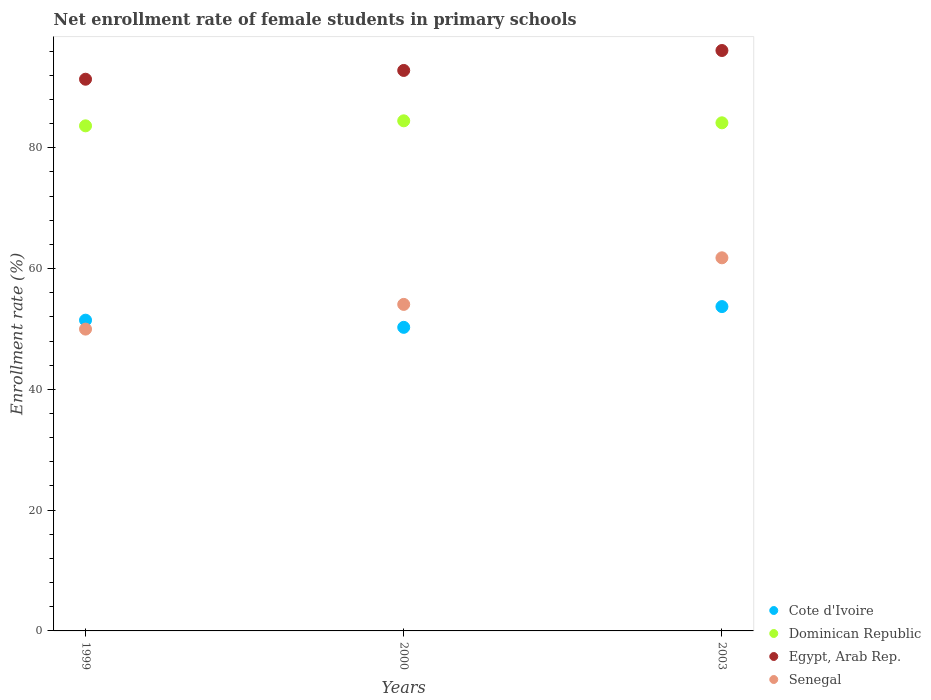Is the number of dotlines equal to the number of legend labels?
Keep it short and to the point. Yes. What is the net enrollment rate of female students in primary schools in Dominican Republic in 2003?
Give a very brief answer. 84.14. Across all years, what is the maximum net enrollment rate of female students in primary schools in Senegal?
Your response must be concise. 61.79. Across all years, what is the minimum net enrollment rate of female students in primary schools in Egypt, Arab Rep.?
Offer a very short reply. 91.36. In which year was the net enrollment rate of female students in primary schools in Egypt, Arab Rep. maximum?
Give a very brief answer. 2003. In which year was the net enrollment rate of female students in primary schools in Senegal minimum?
Provide a short and direct response. 1999. What is the total net enrollment rate of female students in primary schools in Senegal in the graph?
Provide a short and direct response. 165.84. What is the difference between the net enrollment rate of female students in primary schools in Egypt, Arab Rep. in 2000 and that in 2003?
Your response must be concise. -3.3. What is the difference between the net enrollment rate of female students in primary schools in Dominican Republic in 1999 and the net enrollment rate of female students in primary schools in Senegal in 2000?
Keep it short and to the point. 29.57. What is the average net enrollment rate of female students in primary schools in Cote d'Ivoire per year?
Give a very brief answer. 51.81. In the year 2003, what is the difference between the net enrollment rate of female students in primary schools in Egypt, Arab Rep. and net enrollment rate of female students in primary schools in Cote d'Ivoire?
Your response must be concise. 42.41. What is the ratio of the net enrollment rate of female students in primary schools in Dominican Republic in 1999 to that in 2000?
Your response must be concise. 0.99. What is the difference between the highest and the second highest net enrollment rate of female students in primary schools in Dominican Republic?
Make the answer very short. 0.33. What is the difference between the highest and the lowest net enrollment rate of female students in primary schools in Cote d'Ivoire?
Keep it short and to the point. 3.44. Is the sum of the net enrollment rate of female students in primary schools in Dominican Republic in 1999 and 2000 greater than the maximum net enrollment rate of female students in primary schools in Cote d'Ivoire across all years?
Offer a very short reply. Yes. Is it the case that in every year, the sum of the net enrollment rate of female students in primary schools in Egypt, Arab Rep. and net enrollment rate of female students in primary schools in Senegal  is greater than the net enrollment rate of female students in primary schools in Dominican Republic?
Provide a short and direct response. Yes. Does the net enrollment rate of female students in primary schools in Senegal monotonically increase over the years?
Provide a short and direct response. Yes. Is the net enrollment rate of female students in primary schools in Senegal strictly greater than the net enrollment rate of female students in primary schools in Egypt, Arab Rep. over the years?
Offer a very short reply. No. Is the net enrollment rate of female students in primary schools in Dominican Republic strictly less than the net enrollment rate of female students in primary schools in Senegal over the years?
Make the answer very short. No. How many dotlines are there?
Keep it short and to the point. 4. How many years are there in the graph?
Offer a terse response. 3. Does the graph contain any zero values?
Your answer should be very brief. No. Does the graph contain grids?
Make the answer very short. No. Where does the legend appear in the graph?
Make the answer very short. Bottom right. How many legend labels are there?
Ensure brevity in your answer.  4. How are the legend labels stacked?
Offer a very short reply. Vertical. What is the title of the graph?
Offer a very short reply. Net enrollment rate of female students in primary schools. What is the label or title of the Y-axis?
Keep it short and to the point. Enrollment rate (%). What is the Enrollment rate (%) in Cote d'Ivoire in 1999?
Keep it short and to the point. 51.46. What is the Enrollment rate (%) in Dominican Republic in 1999?
Your answer should be very brief. 83.64. What is the Enrollment rate (%) in Egypt, Arab Rep. in 1999?
Your answer should be very brief. 91.36. What is the Enrollment rate (%) in Senegal in 1999?
Give a very brief answer. 49.98. What is the Enrollment rate (%) of Cote d'Ivoire in 2000?
Provide a short and direct response. 50.27. What is the Enrollment rate (%) in Dominican Republic in 2000?
Your answer should be compact. 84.47. What is the Enrollment rate (%) in Egypt, Arab Rep. in 2000?
Ensure brevity in your answer.  92.81. What is the Enrollment rate (%) of Senegal in 2000?
Keep it short and to the point. 54.07. What is the Enrollment rate (%) in Cote d'Ivoire in 2003?
Your answer should be compact. 53.71. What is the Enrollment rate (%) of Dominican Republic in 2003?
Provide a short and direct response. 84.14. What is the Enrollment rate (%) in Egypt, Arab Rep. in 2003?
Your answer should be compact. 96.12. What is the Enrollment rate (%) of Senegal in 2003?
Offer a very short reply. 61.79. Across all years, what is the maximum Enrollment rate (%) in Cote d'Ivoire?
Provide a short and direct response. 53.71. Across all years, what is the maximum Enrollment rate (%) of Dominican Republic?
Give a very brief answer. 84.47. Across all years, what is the maximum Enrollment rate (%) of Egypt, Arab Rep.?
Make the answer very short. 96.12. Across all years, what is the maximum Enrollment rate (%) of Senegal?
Keep it short and to the point. 61.79. Across all years, what is the minimum Enrollment rate (%) in Cote d'Ivoire?
Keep it short and to the point. 50.27. Across all years, what is the minimum Enrollment rate (%) of Dominican Republic?
Give a very brief answer. 83.64. Across all years, what is the minimum Enrollment rate (%) of Egypt, Arab Rep.?
Keep it short and to the point. 91.36. Across all years, what is the minimum Enrollment rate (%) in Senegal?
Keep it short and to the point. 49.98. What is the total Enrollment rate (%) in Cote d'Ivoire in the graph?
Make the answer very short. 155.44. What is the total Enrollment rate (%) of Dominican Republic in the graph?
Offer a very short reply. 252.25. What is the total Enrollment rate (%) of Egypt, Arab Rep. in the graph?
Keep it short and to the point. 280.29. What is the total Enrollment rate (%) in Senegal in the graph?
Your answer should be compact. 165.84. What is the difference between the Enrollment rate (%) in Cote d'Ivoire in 1999 and that in 2000?
Ensure brevity in your answer.  1.19. What is the difference between the Enrollment rate (%) of Dominican Republic in 1999 and that in 2000?
Your answer should be compact. -0.83. What is the difference between the Enrollment rate (%) in Egypt, Arab Rep. in 1999 and that in 2000?
Keep it short and to the point. -1.45. What is the difference between the Enrollment rate (%) in Senegal in 1999 and that in 2000?
Ensure brevity in your answer.  -4.09. What is the difference between the Enrollment rate (%) in Cote d'Ivoire in 1999 and that in 2003?
Ensure brevity in your answer.  -2.25. What is the difference between the Enrollment rate (%) in Dominican Republic in 1999 and that in 2003?
Your answer should be very brief. -0.5. What is the difference between the Enrollment rate (%) in Egypt, Arab Rep. in 1999 and that in 2003?
Your answer should be very brief. -4.76. What is the difference between the Enrollment rate (%) of Senegal in 1999 and that in 2003?
Provide a short and direct response. -11.81. What is the difference between the Enrollment rate (%) in Cote d'Ivoire in 2000 and that in 2003?
Your answer should be very brief. -3.44. What is the difference between the Enrollment rate (%) of Dominican Republic in 2000 and that in 2003?
Ensure brevity in your answer.  0.33. What is the difference between the Enrollment rate (%) in Egypt, Arab Rep. in 2000 and that in 2003?
Your response must be concise. -3.3. What is the difference between the Enrollment rate (%) of Senegal in 2000 and that in 2003?
Your answer should be very brief. -7.72. What is the difference between the Enrollment rate (%) in Cote d'Ivoire in 1999 and the Enrollment rate (%) in Dominican Republic in 2000?
Give a very brief answer. -33.01. What is the difference between the Enrollment rate (%) of Cote d'Ivoire in 1999 and the Enrollment rate (%) of Egypt, Arab Rep. in 2000?
Keep it short and to the point. -41.35. What is the difference between the Enrollment rate (%) in Cote d'Ivoire in 1999 and the Enrollment rate (%) in Senegal in 2000?
Provide a short and direct response. -2.61. What is the difference between the Enrollment rate (%) in Dominican Republic in 1999 and the Enrollment rate (%) in Egypt, Arab Rep. in 2000?
Ensure brevity in your answer.  -9.17. What is the difference between the Enrollment rate (%) of Dominican Republic in 1999 and the Enrollment rate (%) of Senegal in 2000?
Your answer should be compact. 29.57. What is the difference between the Enrollment rate (%) in Egypt, Arab Rep. in 1999 and the Enrollment rate (%) in Senegal in 2000?
Make the answer very short. 37.29. What is the difference between the Enrollment rate (%) of Cote d'Ivoire in 1999 and the Enrollment rate (%) of Dominican Republic in 2003?
Ensure brevity in your answer.  -32.68. What is the difference between the Enrollment rate (%) of Cote d'Ivoire in 1999 and the Enrollment rate (%) of Egypt, Arab Rep. in 2003?
Offer a terse response. -44.66. What is the difference between the Enrollment rate (%) in Cote d'Ivoire in 1999 and the Enrollment rate (%) in Senegal in 2003?
Ensure brevity in your answer.  -10.33. What is the difference between the Enrollment rate (%) of Dominican Republic in 1999 and the Enrollment rate (%) of Egypt, Arab Rep. in 2003?
Ensure brevity in your answer.  -12.47. What is the difference between the Enrollment rate (%) of Dominican Republic in 1999 and the Enrollment rate (%) of Senegal in 2003?
Provide a short and direct response. 21.85. What is the difference between the Enrollment rate (%) of Egypt, Arab Rep. in 1999 and the Enrollment rate (%) of Senegal in 2003?
Provide a succinct answer. 29.57. What is the difference between the Enrollment rate (%) in Cote d'Ivoire in 2000 and the Enrollment rate (%) in Dominican Republic in 2003?
Your answer should be compact. -33.87. What is the difference between the Enrollment rate (%) in Cote d'Ivoire in 2000 and the Enrollment rate (%) in Egypt, Arab Rep. in 2003?
Your answer should be compact. -45.84. What is the difference between the Enrollment rate (%) of Cote d'Ivoire in 2000 and the Enrollment rate (%) of Senegal in 2003?
Offer a terse response. -11.52. What is the difference between the Enrollment rate (%) in Dominican Republic in 2000 and the Enrollment rate (%) in Egypt, Arab Rep. in 2003?
Make the answer very short. -11.64. What is the difference between the Enrollment rate (%) in Dominican Republic in 2000 and the Enrollment rate (%) in Senegal in 2003?
Make the answer very short. 22.68. What is the difference between the Enrollment rate (%) in Egypt, Arab Rep. in 2000 and the Enrollment rate (%) in Senegal in 2003?
Make the answer very short. 31.03. What is the average Enrollment rate (%) in Cote d'Ivoire per year?
Ensure brevity in your answer.  51.81. What is the average Enrollment rate (%) of Dominican Republic per year?
Keep it short and to the point. 84.08. What is the average Enrollment rate (%) in Egypt, Arab Rep. per year?
Make the answer very short. 93.43. What is the average Enrollment rate (%) of Senegal per year?
Make the answer very short. 55.28. In the year 1999, what is the difference between the Enrollment rate (%) in Cote d'Ivoire and Enrollment rate (%) in Dominican Republic?
Keep it short and to the point. -32.18. In the year 1999, what is the difference between the Enrollment rate (%) of Cote d'Ivoire and Enrollment rate (%) of Egypt, Arab Rep.?
Offer a very short reply. -39.9. In the year 1999, what is the difference between the Enrollment rate (%) in Cote d'Ivoire and Enrollment rate (%) in Senegal?
Give a very brief answer. 1.48. In the year 1999, what is the difference between the Enrollment rate (%) in Dominican Republic and Enrollment rate (%) in Egypt, Arab Rep.?
Give a very brief answer. -7.72. In the year 1999, what is the difference between the Enrollment rate (%) in Dominican Republic and Enrollment rate (%) in Senegal?
Your response must be concise. 33.66. In the year 1999, what is the difference between the Enrollment rate (%) of Egypt, Arab Rep. and Enrollment rate (%) of Senegal?
Make the answer very short. 41.38. In the year 2000, what is the difference between the Enrollment rate (%) in Cote d'Ivoire and Enrollment rate (%) in Dominican Republic?
Ensure brevity in your answer.  -34.2. In the year 2000, what is the difference between the Enrollment rate (%) of Cote d'Ivoire and Enrollment rate (%) of Egypt, Arab Rep.?
Make the answer very short. -42.54. In the year 2000, what is the difference between the Enrollment rate (%) of Cote d'Ivoire and Enrollment rate (%) of Senegal?
Ensure brevity in your answer.  -3.8. In the year 2000, what is the difference between the Enrollment rate (%) of Dominican Republic and Enrollment rate (%) of Egypt, Arab Rep.?
Your answer should be compact. -8.34. In the year 2000, what is the difference between the Enrollment rate (%) of Dominican Republic and Enrollment rate (%) of Senegal?
Your answer should be very brief. 30.4. In the year 2000, what is the difference between the Enrollment rate (%) of Egypt, Arab Rep. and Enrollment rate (%) of Senegal?
Offer a very short reply. 38.74. In the year 2003, what is the difference between the Enrollment rate (%) of Cote d'Ivoire and Enrollment rate (%) of Dominican Republic?
Offer a terse response. -30.43. In the year 2003, what is the difference between the Enrollment rate (%) in Cote d'Ivoire and Enrollment rate (%) in Egypt, Arab Rep.?
Provide a short and direct response. -42.41. In the year 2003, what is the difference between the Enrollment rate (%) in Cote d'Ivoire and Enrollment rate (%) in Senegal?
Provide a succinct answer. -8.08. In the year 2003, what is the difference between the Enrollment rate (%) in Dominican Republic and Enrollment rate (%) in Egypt, Arab Rep.?
Make the answer very short. -11.97. In the year 2003, what is the difference between the Enrollment rate (%) of Dominican Republic and Enrollment rate (%) of Senegal?
Your answer should be very brief. 22.35. In the year 2003, what is the difference between the Enrollment rate (%) of Egypt, Arab Rep. and Enrollment rate (%) of Senegal?
Provide a succinct answer. 34.33. What is the ratio of the Enrollment rate (%) of Cote d'Ivoire in 1999 to that in 2000?
Make the answer very short. 1.02. What is the ratio of the Enrollment rate (%) in Dominican Republic in 1999 to that in 2000?
Your answer should be compact. 0.99. What is the ratio of the Enrollment rate (%) in Egypt, Arab Rep. in 1999 to that in 2000?
Provide a short and direct response. 0.98. What is the ratio of the Enrollment rate (%) of Senegal in 1999 to that in 2000?
Your response must be concise. 0.92. What is the ratio of the Enrollment rate (%) in Cote d'Ivoire in 1999 to that in 2003?
Make the answer very short. 0.96. What is the ratio of the Enrollment rate (%) in Dominican Republic in 1999 to that in 2003?
Offer a terse response. 0.99. What is the ratio of the Enrollment rate (%) in Egypt, Arab Rep. in 1999 to that in 2003?
Offer a terse response. 0.95. What is the ratio of the Enrollment rate (%) in Senegal in 1999 to that in 2003?
Provide a succinct answer. 0.81. What is the ratio of the Enrollment rate (%) of Cote d'Ivoire in 2000 to that in 2003?
Your response must be concise. 0.94. What is the ratio of the Enrollment rate (%) of Dominican Republic in 2000 to that in 2003?
Your answer should be compact. 1. What is the ratio of the Enrollment rate (%) of Egypt, Arab Rep. in 2000 to that in 2003?
Your answer should be compact. 0.97. What is the ratio of the Enrollment rate (%) of Senegal in 2000 to that in 2003?
Keep it short and to the point. 0.88. What is the difference between the highest and the second highest Enrollment rate (%) in Cote d'Ivoire?
Keep it short and to the point. 2.25. What is the difference between the highest and the second highest Enrollment rate (%) of Dominican Republic?
Make the answer very short. 0.33. What is the difference between the highest and the second highest Enrollment rate (%) in Egypt, Arab Rep.?
Your response must be concise. 3.3. What is the difference between the highest and the second highest Enrollment rate (%) in Senegal?
Ensure brevity in your answer.  7.72. What is the difference between the highest and the lowest Enrollment rate (%) of Cote d'Ivoire?
Make the answer very short. 3.44. What is the difference between the highest and the lowest Enrollment rate (%) of Dominican Republic?
Offer a terse response. 0.83. What is the difference between the highest and the lowest Enrollment rate (%) in Egypt, Arab Rep.?
Offer a terse response. 4.76. What is the difference between the highest and the lowest Enrollment rate (%) of Senegal?
Offer a very short reply. 11.81. 